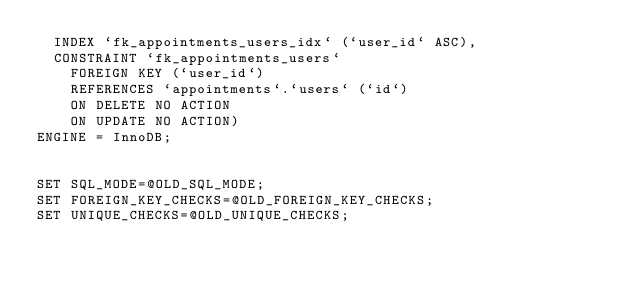<code> <loc_0><loc_0><loc_500><loc_500><_SQL_>  INDEX `fk_appointments_users_idx` (`user_id` ASC),
  CONSTRAINT `fk_appointments_users`
    FOREIGN KEY (`user_id`)
    REFERENCES `appointments`.`users` (`id`)
    ON DELETE NO ACTION
    ON UPDATE NO ACTION)
ENGINE = InnoDB;


SET SQL_MODE=@OLD_SQL_MODE;
SET FOREIGN_KEY_CHECKS=@OLD_FOREIGN_KEY_CHECKS;
SET UNIQUE_CHECKS=@OLD_UNIQUE_CHECKS;
</code> 